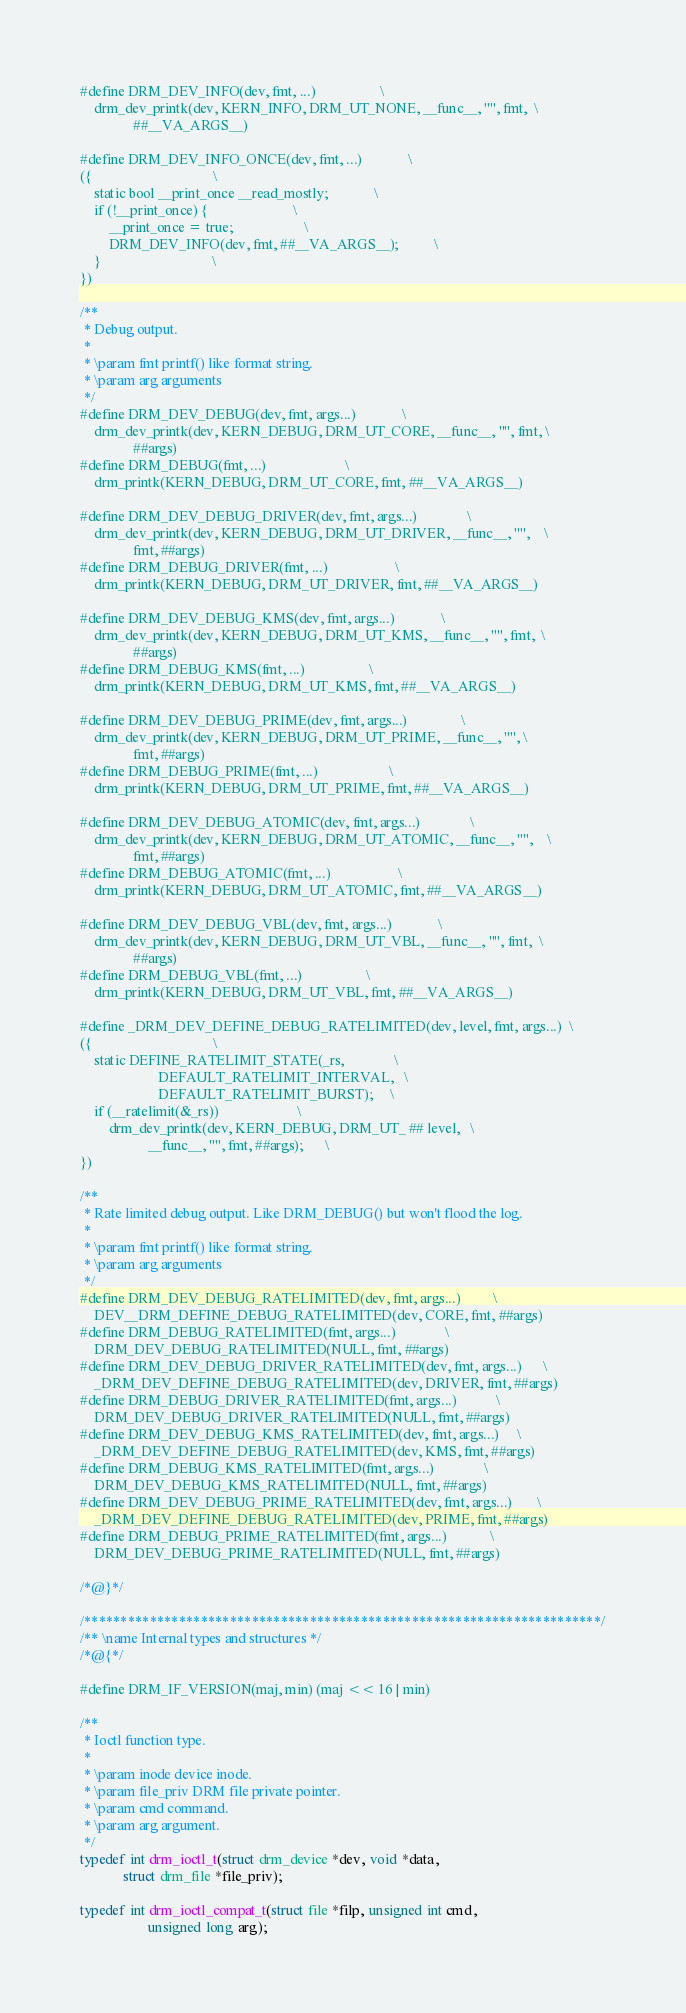<code> <loc_0><loc_0><loc_500><loc_500><_C_>#define DRM_DEV_INFO(dev, fmt, ...)					\
	drm_dev_printk(dev, KERN_INFO, DRM_UT_NONE, __func__, "", fmt,	\
		       ##__VA_ARGS__)

#define DRM_DEV_INFO_ONCE(dev, fmt, ...)				\
({									\
	static bool __print_once __read_mostly;				\
	if (!__print_once) {						\
		__print_once = true;					\
		DRM_DEV_INFO(dev, fmt, ##__VA_ARGS__);			\
	}								\
})

/**
 * Debug output.
 *
 * \param fmt printf() like format string.
 * \param arg arguments
 */
#define DRM_DEV_DEBUG(dev, fmt, args...)				\
	drm_dev_printk(dev, KERN_DEBUG, DRM_UT_CORE, __func__, "", fmt,	\
		       ##args)
#define DRM_DEBUG(fmt, ...)						\
	drm_printk(KERN_DEBUG, DRM_UT_CORE, fmt, ##__VA_ARGS__)

#define DRM_DEV_DEBUG_DRIVER(dev, fmt, args...)				\
	drm_dev_printk(dev, KERN_DEBUG, DRM_UT_DRIVER, __func__, "",	\
		       fmt, ##args)
#define DRM_DEBUG_DRIVER(fmt, ...)					\
	drm_printk(KERN_DEBUG, DRM_UT_DRIVER, fmt, ##__VA_ARGS__)

#define DRM_DEV_DEBUG_KMS(dev, fmt, args...)				\
	drm_dev_printk(dev, KERN_DEBUG, DRM_UT_KMS, __func__, "", fmt,	\
		       ##args)
#define DRM_DEBUG_KMS(fmt, ...)					\
	drm_printk(KERN_DEBUG, DRM_UT_KMS, fmt, ##__VA_ARGS__)

#define DRM_DEV_DEBUG_PRIME(dev, fmt, args...)				\
	drm_dev_printk(dev, KERN_DEBUG, DRM_UT_PRIME, __func__, "",	\
		       fmt, ##args)
#define DRM_DEBUG_PRIME(fmt, ...)					\
	drm_printk(KERN_DEBUG, DRM_UT_PRIME, fmt, ##__VA_ARGS__)

#define DRM_DEV_DEBUG_ATOMIC(dev, fmt, args...)				\
	drm_dev_printk(dev, KERN_DEBUG, DRM_UT_ATOMIC, __func__, "",	\
		       fmt, ##args)
#define DRM_DEBUG_ATOMIC(fmt, ...)					\
	drm_printk(KERN_DEBUG, DRM_UT_ATOMIC, fmt, ##__VA_ARGS__)

#define DRM_DEV_DEBUG_VBL(dev, fmt, args...)				\
	drm_dev_printk(dev, KERN_DEBUG, DRM_UT_VBL, __func__, "", fmt,	\
		       ##args)
#define DRM_DEBUG_VBL(fmt, ...)					\
	drm_printk(KERN_DEBUG, DRM_UT_VBL, fmt, ##__VA_ARGS__)

#define _DRM_DEV_DEFINE_DEBUG_RATELIMITED(dev, level, fmt, args...)	\
({									\
	static DEFINE_RATELIMIT_STATE(_rs,				\
				      DEFAULT_RATELIMIT_INTERVAL,	\
				      DEFAULT_RATELIMIT_BURST);		\
	if (__ratelimit(&_rs))						\
		drm_dev_printk(dev, KERN_DEBUG, DRM_UT_ ## level,	\
			       __func__, "", fmt, ##args);		\
})

/**
 * Rate limited debug output. Like DRM_DEBUG() but won't flood the log.
 *
 * \param fmt printf() like format string.
 * \param arg arguments
 */
#define DRM_DEV_DEBUG_RATELIMITED(dev, fmt, args...)			\
	DEV__DRM_DEFINE_DEBUG_RATELIMITED(dev, CORE, fmt, ##args)
#define DRM_DEBUG_RATELIMITED(fmt, args...)				\
	DRM_DEV_DEBUG_RATELIMITED(NULL, fmt, ##args)
#define DRM_DEV_DEBUG_DRIVER_RATELIMITED(dev, fmt, args...)		\
	_DRM_DEV_DEFINE_DEBUG_RATELIMITED(dev, DRIVER, fmt, ##args)
#define DRM_DEBUG_DRIVER_RATELIMITED(fmt, args...)			\
	DRM_DEV_DEBUG_DRIVER_RATELIMITED(NULL, fmt, ##args)
#define DRM_DEV_DEBUG_KMS_RATELIMITED(dev, fmt, args...)		\
	_DRM_DEV_DEFINE_DEBUG_RATELIMITED(dev, KMS, fmt, ##args)
#define DRM_DEBUG_KMS_RATELIMITED(fmt, args...)				\
	DRM_DEV_DEBUG_KMS_RATELIMITED(NULL, fmt, ##args)
#define DRM_DEV_DEBUG_PRIME_RATELIMITED(dev, fmt, args...)		\
	_DRM_DEV_DEFINE_DEBUG_RATELIMITED(dev, PRIME, fmt, ##args)
#define DRM_DEBUG_PRIME_RATELIMITED(fmt, args...)			\
	DRM_DEV_DEBUG_PRIME_RATELIMITED(NULL, fmt, ##args)

/*@}*/

/***********************************************************************/
/** \name Internal types and structures */
/*@{*/

#define DRM_IF_VERSION(maj, min) (maj << 16 | min)

/**
 * Ioctl function type.
 *
 * \param inode device inode.
 * \param file_priv DRM file private pointer.
 * \param cmd command.
 * \param arg argument.
 */
typedef int drm_ioctl_t(struct drm_device *dev, void *data,
			struct drm_file *file_priv);

typedef int drm_ioctl_compat_t(struct file *filp, unsigned int cmd,
			       unsigned long arg);
</code> 